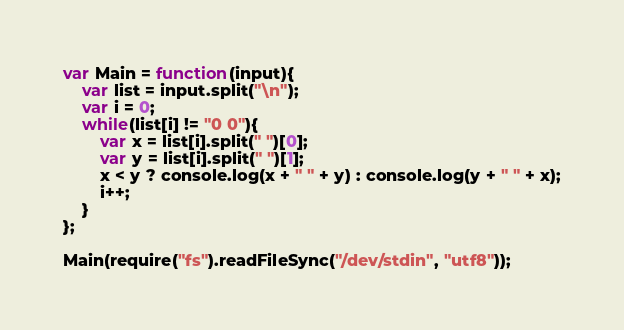Convert code to text. <code><loc_0><loc_0><loc_500><loc_500><_JavaScript_>var Main = function(input){
	var list = input.split("\n");
	var i = 0;
	while(list[i] != "0 0"){
		var x = list[i].split(" ")[0];
		var y = list[i].split(" ")[1];
		x < y ? console.log(x + " " + y) : console.log(y + " " + x);
		i++;
	}
};

Main(require("fs").readFileSync("/dev/stdin", "utf8"));</code> 